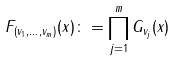Convert formula to latex. <formula><loc_0><loc_0><loc_500><loc_500>F _ { ( v _ { 1 } , \dots , v _ { m } ) } ( x ) \colon = \prod _ { j = 1 } ^ { m } G _ { v _ { j } } ( x )</formula> 